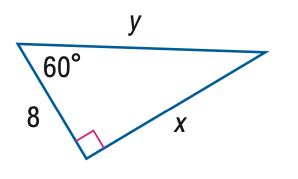Answer the mathemtical geometry problem and directly provide the correct option letter.
Question: Find x.
Choices: A: 8 B: 11.3 C: 13.9 D: 16 C 